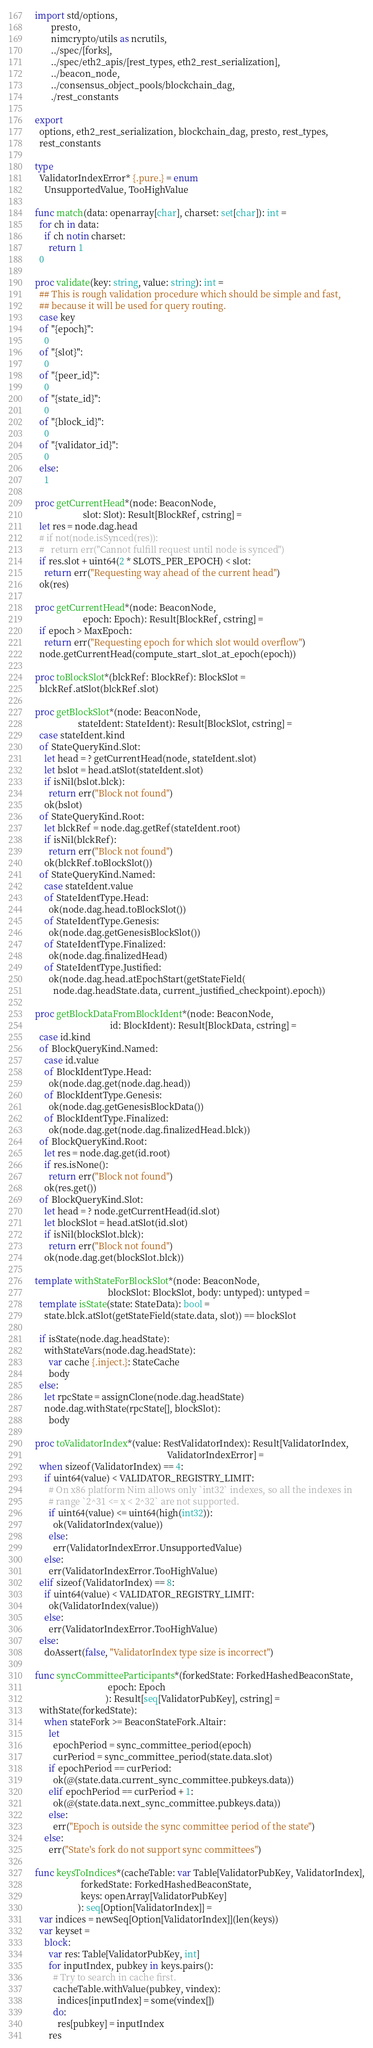Convert code to text. <code><loc_0><loc_0><loc_500><loc_500><_Nim_>import std/options,
       presto,
       nimcrypto/utils as ncrutils,
       ../spec/[forks],
       ../spec/eth2_apis/[rest_types, eth2_rest_serialization],
       ../beacon_node,
       ../consensus_object_pools/blockchain_dag,
       ./rest_constants

export
  options, eth2_rest_serialization, blockchain_dag, presto, rest_types,
  rest_constants

type
  ValidatorIndexError* {.pure.} = enum
    UnsupportedValue, TooHighValue

func match(data: openarray[char], charset: set[char]): int =
  for ch in data:
    if ch notin charset:
      return 1
  0

proc validate(key: string, value: string): int =
  ## This is rough validation procedure which should be simple and fast,
  ## because it will be used for query routing.
  case key
  of "{epoch}":
    0
  of "{slot}":
    0
  of "{peer_id}":
    0
  of "{state_id}":
    0
  of "{block_id}":
    0
  of "{validator_id}":
    0
  else:
    1

proc getCurrentHead*(node: BeaconNode,
                     slot: Slot): Result[BlockRef, cstring] =
  let res = node.dag.head
  # if not(node.isSynced(res)):
  #   return err("Cannot fulfill request until node is synced")
  if res.slot + uint64(2 * SLOTS_PER_EPOCH) < slot:
    return err("Requesting way ahead of the current head")
  ok(res)

proc getCurrentHead*(node: BeaconNode,
                     epoch: Epoch): Result[BlockRef, cstring] =
  if epoch > MaxEpoch:
    return err("Requesting epoch for which slot would overflow")
  node.getCurrentHead(compute_start_slot_at_epoch(epoch))

proc toBlockSlot*(blckRef: BlockRef): BlockSlot =
  blckRef.atSlot(blckRef.slot)

proc getBlockSlot*(node: BeaconNode,
                   stateIdent: StateIdent): Result[BlockSlot, cstring] =
  case stateIdent.kind
  of StateQueryKind.Slot:
    let head = ? getCurrentHead(node, stateIdent.slot)
    let bslot = head.atSlot(stateIdent.slot)
    if isNil(bslot.blck):
      return err("Block not found")
    ok(bslot)
  of StateQueryKind.Root:
    let blckRef = node.dag.getRef(stateIdent.root)
    if isNil(blckRef):
      return err("Block not found")
    ok(blckRef.toBlockSlot())
  of StateQueryKind.Named:
    case stateIdent.value
    of StateIdentType.Head:
      ok(node.dag.head.toBlockSlot())
    of StateIdentType.Genesis:
      ok(node.dag.getGenesisBlockSlot())
    of StateIdentType.Finalized:
      ok(node.dag.finalizedHead)
    of StateIdentType.Justified:
      ok(node.dag.head.atEpochStart(getStateField(
        node.dag.headState.data, current_justified_checkpoint).epoch))

proc getBlockDataFromBlockIdent*(node: BeaconNode,
                                 id: BlockIdent): Result[BlockData, cstring] =
  case id.kind
  of BlockQueryKind.Named:
    case id.value
    of BlockIdentType.Head:
      ok(node.dag.get(node.dag.head))
    of BlockIdentType.Genesis:
      ok(node.dag.getGenesisBlockData())
    of BlockIdentType.Finalized:
      ok(node.dag.get(node.dag.finalizedHead.blck))
  of BlockQueryKind.Root:
    let res = node.dag.get(id.root)
    if res.isNone():
      return err("Block not found")
    ok(res.get())
  of BlockQueryKind.Slot:
    let head = ? node.getCurrentHead(id.slot)
    let blockSlot = head.atSlot(id.slot)
    if isNil(blockSlot.blck):
      return err("Block not found")
    ok(node.dag.get(blockSlot.blck))

template withStateForBlockSlot*(node: BeaconNode,
                                blockSlot: BlockSlot, body: untyped): untyped =
  template isState(state: StateData): bool =
    state.blck.atSlot(getStateField(state.data, slot)) == blockSlot

  if isState(node.dag.headState):
    withStateVars(node.dag.headState):
      var cache {.inject.}: StateCache
      body
  else:
    let rpcState = assignClone(node.dag.headState)
    node.dag.withState(rpcState[], blockSlot):
      body

proc toValidatorIndex*(value: RestValidatorIndex): Result[ValidatorIndex,
                                                          ValidatorIndexError] =
  when sizeof(ValidatorIndex) == 4:
    if uint64(value) < VALIDATOR_REGISTRY_LIMIT:
      # On x86 platform Nim allows only `int32` indexes, so all the indexes in
      # range `2^31 <= x < 2^32` are not supported.
      if uint64(value) <= uint64(high(int32)):
        ok(ValidatorIndex(value))
      else:
        err(ValidatorIndexError.UnsupportedValue)
    else:
      err(ValidatorIndexError.TooHighValue)
  elif sizeof(ValidatorIndex) == 8:
    if uint64(value) < VALIDATOR_REGISTRY_LIMIT:
      ok(ValidatorIndex(value))
    else:
      err(ValidatorIndexError.TooHighValue)
  else:
    doAssert(false, "ValidatorIndex type size is incorrect")

func syncCommitteeParticipants*(forkedState: ForkedHashedBeaconState,
                                epoch: Epoch
                               ): Result[seq[ValidatorPubKey], cstring] =
  withState(forkedState):
    when stateFork >= BeaconStateFork.Altair:
      let
        epochPeriod = sync_committee_period(epoch)
        curPeriod = sync_committee_period(state.data.slot)
      if epochPeriod == curPeriod:
        ok(@(state.data.current_sync_committee.pubkeys.data))
      elif epochPeriod == curPeriod + 1:
        ok(@(state.data.next_sync_committee.pubkeys.data))
      else:
        err("Epoch is outside the sync committee period of the state")
    else:
      err("State's fork do not support sync committees")

func keysToIndices*(cacheTable: var Table[ValidatorPubKey, ValidatorIndex],
                    forkedState: ForkedHashedBeaconState,
                    keys: openArray[ValidatorPubKey]
                   ): seq[Option[ValidatorIndex]] =
  var indices = newSeq[Option[ValidatorIndex]](len(keys))
  var keyset =
    block:
      var res: Table[ValidatorPubKey, int]
      for inputIndex, pubkey in keys.pairs():
        # Try to search in cache first.
        cacheTable.withValue(pubkey, vindex):
          indices[inputIndex] = some(vindex[])
        do:
          res[pubkey] = inputIndex
      res</code> 